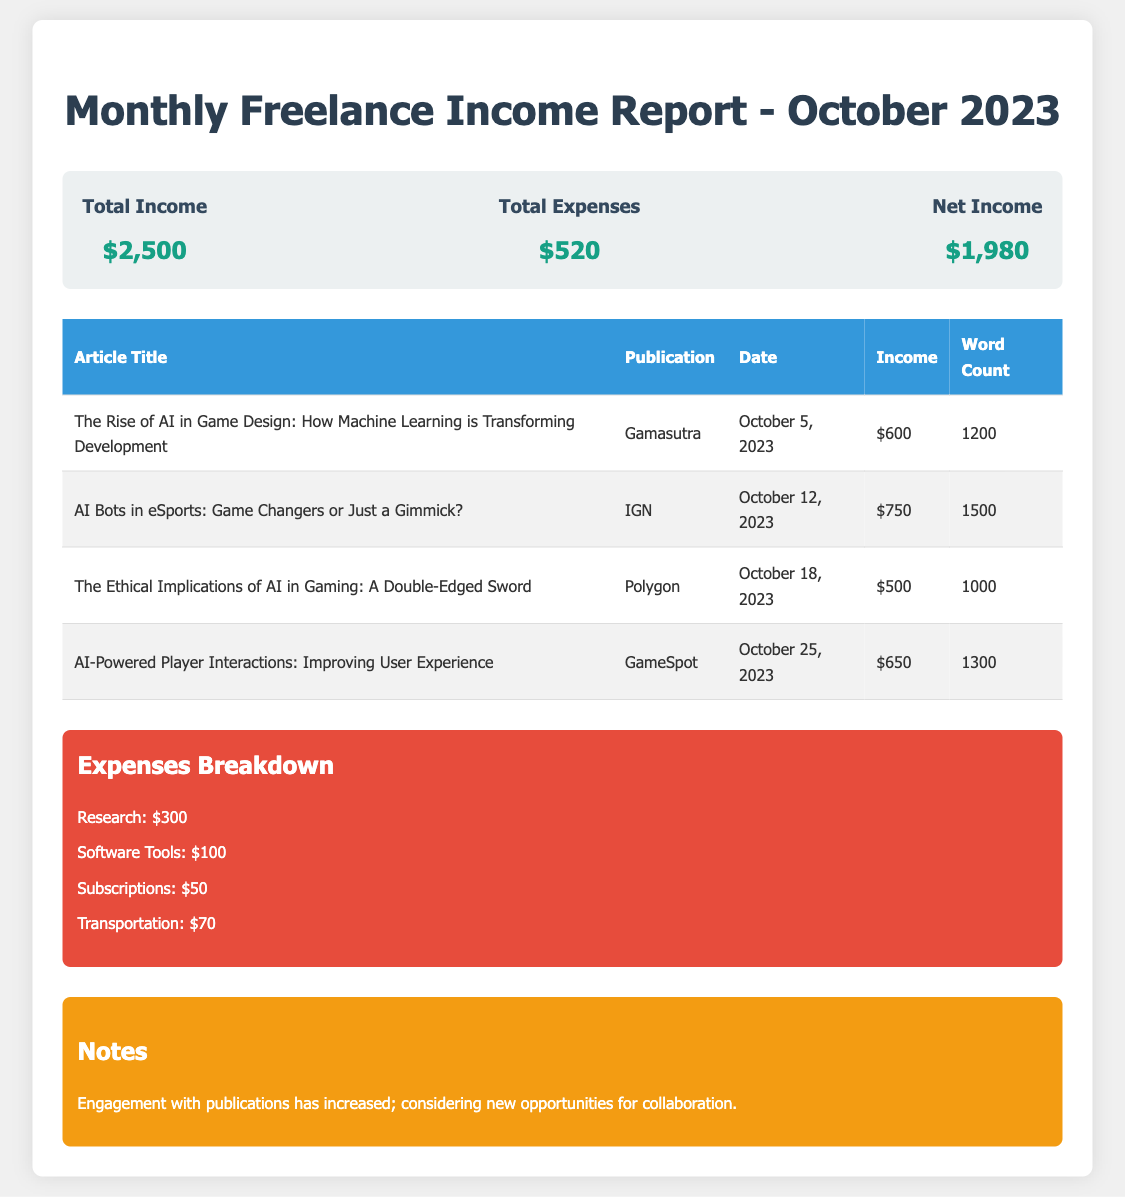What is the total income? The total income is presented in the summary section of the document, which states $2,500.
Answer: $2,500 What is the total expenses? The summary section indicates the total expenses incurred, which is $520.
Answer: $520 What is the net income? The net income is calculated by subtracting total expenses from total income, given as $1,980 in the summary.
Answer: $1,980 How many articles were reported in this month? There are a total of 4 articles listed in the table section of the report.
Answer: 4 Which publication featured the article titled "AI Bots in eSports: Game Changers or Just a Gimmick?" The article was published in IGN, as shown in the table.
Answer: IGN What was the income for the article "The Ethical Implications of AI in Gaming: A Double-Edged Sword"? The income for that article is reported as $500 in the income table.
Answer: $500 What is the highest income earned from a single article? The highest income from a single article is $750 for the article in IGN.
Answer: $750 What was the biggest expense category? The biggest expense category listed is Research, which amounts to $300.
Answer: Research What note is provided regarding publication engagement? The note states that engagement with publications has increased, suggesting opportunities for collaboration.
Answer: Engagement with publications has increased; considering new opportunities for collaboration 